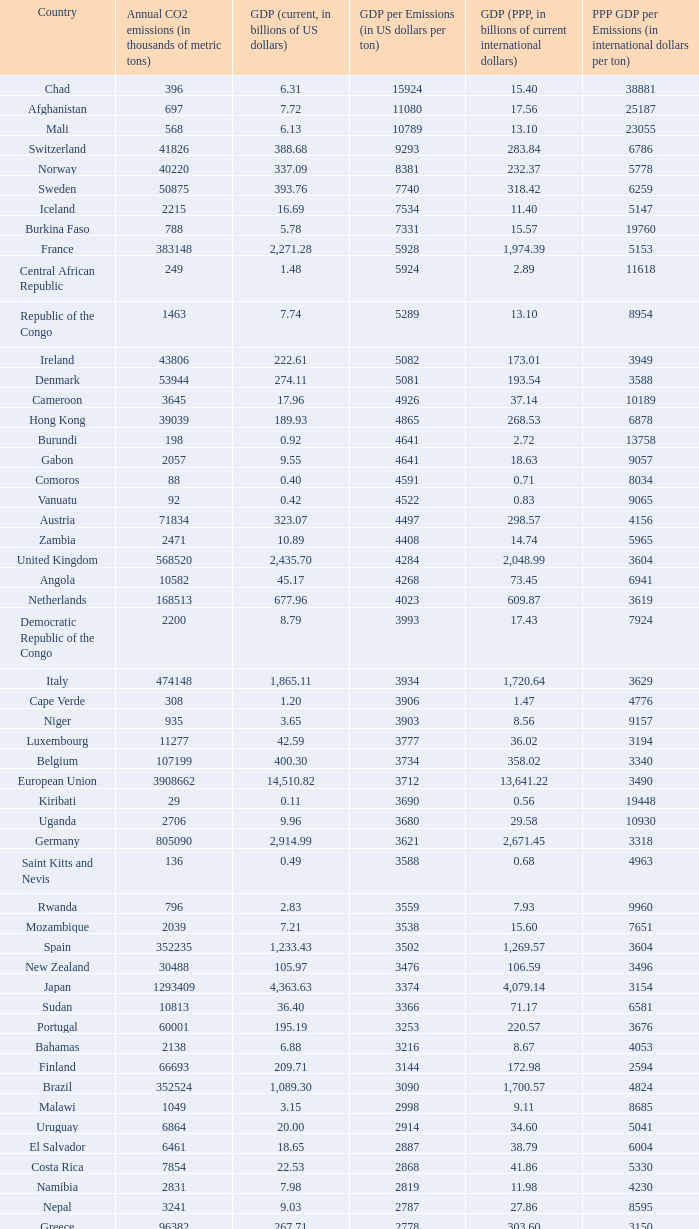What is the highest gdp (ppp, in billions of current international dollars) per emissions (in international dollars per ton) when the gdp (ppp) is 7.93? 9960.0. Parse the full table. {'header': ['Country', 'Annual CO2 emissions (in thousands of metric tons)', 'GDP (current, in billions of US dollars)', 'GDP per Emissions (in US dollars per ton)', 'GDP (PPP, in billions of current international dollars)', 'PPP GDP per Emissions (in international dollars per ton)'], 'rows': [['Chad', '396', '6.31', '15924', '15.40', '38881'], ['Afghanistan', '697', '7.72', '11080', '17.56', '25187'], ['Mali', '568', '6.13', '10789', '13.10', '23055'], ['Switzerland', '41826', '388.68', '9293', '283.84', '6786'], ['Norway', '40220', '337.09', '8381', '232.37', '5778'], ['Sweden', '50875', '393.76', '7740', '318.42', '6259'], ['Iceland', '2215', '16.69', '7534', '11.40', '5147'], ['Burkina Faso', '788', '5.78', '7331', '15.57', '19760'], ['France', '383148', '2,271.28', '5928', '1,974.39', '5153'], ['Central African Republic', '249', '1.48', '5924', '2.89', '11618'], ['Republic of the Congo', '1463', '7.74', '5289', '13.10', '8954'], ['Ireland', '43806', '222.61', '5082', '173.01', '3949'], ['Denmark', '53944', '274.11', '5081', '193.54', '3588'], ['Cameroon', '3645', '17.96', '4926', '37.14', '10189'], ['Hong Kong', '39039', '189.93', '4865', '268.53', '6878'], ['Burundi', '198', '0.92', '4641', '2.72', '13758'], ['Gabon', '2057', '9.55', '4641', '18.63', '9057'], ['Comoros', '88', '0.40', '4591', '0.71', '8034'], ['Vanuatu', '92', '0.42', '4522', '0.83', '9065'], ['Austria', '71834', '323.07', '4497', '298.57', '4156'], ['Zambia', '2471', '10.89', '4408', '14.74', '5965'], ['United Kingdom', '568520', '2,435.70', '4284', '2,048.99', '3604'], ['Angola', '10582', '45.17', '4268', '73.45', '6941'], ['Netherlands', '168513', '677.96', '4023', '609.87', '3619'], ['Democratic Republic of the Congo', '2200', '8.79', '3993', '17.43', '7924'], ['Italy', '474148', '1,865.11', '3934', '1,720.64', '3629'], ['Cape Verde', '308', '1.20', '3906', '1.47', '4776'], ['Niger', '935', '3.65', '3903', '8.56', '9157'], ['Luxembourg', '11277', '42.59', '3777', '36.02', '3194'], ['Belgium', '107199', '400.30', '3734', '358.02', '3340'], ['European Union', '3908662', '14,510.82', '3712', '13,641.22', '3490'], ['Kiribati', '29', '0.11', '3690', '0.56', '19448'], ['Uganda', '2706', '9.96', '3680', '29.58', '10930'], ['Germany', '805090', '2,914.99', '3621', '2,671.45', '3318'], ['Saint Kitts and Nevis', '136', '0.49', '3588', '0.68', '4963'], ['Rwanda', '796', '2.83', '3559', '7.93', '9960'], ['Mozambique', '2039', '7.21', '3538', '15.60', '7651'], ['Spain', '352235', '1,233.43', '3502', '1,269.57', '3604'], ['New Zealand', '30488', '105.97', '3476', '106.59', '3496'], ['Japan', '1293409', '4,363.63', '3374', '4,079.14', '3154'], ['Sudan', '10813', '36.40', '3366', '71.17', '6581'], ['Portugal', '60001', '195.19', '3253', '220.57', '3676'], ['Bahamas', '2138', '6.88', '3216', '8.67', '4053'], ['Finland', '66693', '209.71', '3144', '172.98', '2594'], ['Brazil', '352524', '1,089.30', '3090', '1,700.57', '4824'], ['Malawi', '1049', '3.15', '2998', '9.11', '8685'], ['Uruguay', '6864', '20.00', '2914', '34.60', '5041'], ['El Salvador', '6461', '18.65', '2887', '38.79', '6004'], ['Costa Rica', '7854', '22.53', '2868', '41.86', '5330'], ['Namibia', '2831', '7.98', '2819', '11.98', '4230'], ['Nepal', '3241', '9.03', '2787', '27.86', '8595'], ['Greece', '96382', '267.71', '2778', '303.60', '3150'], ['Samoa', '158', '0.43', '2747', '0.95', '5987'], ['Dominica', '117', '0.32', '2709', '0.66', '5632'], ['Latvia', '7462', '19.94', '2672', '35.22', '4720'], ['Tanzania', '5372', '14.35', '2671', '44.46', '8276'], ['Haiti', '1811', '4.84', '2670', '10.52', '5809'], ['Panama', '6428', '17.13', '2666', '30.21', '4700'], ['Swaziland', '1016', '2.67', '2629', '5.18', '5095'], ['Guatemala', '11766', '30.26', '2572', '57.77', '4910'], ['Slovenia', '15173', '38.94', '2566', '51.14', '3370'], ['Colombia', '63422', '162.50', '2562', '342.77', '5405'], ['Malta', '2548', '6.44', '2528', '8.88', '3485'], ['Ivory Coast', '6882', '17.38', '2526', '31.22', '4536'], ['Ethiopia', '6006', '15.17', '2525', '54.39', '9055'], ['Saint Lucia', '367', '0.93', '2520', '1.69', '4616'], ['Saint Vincent and the Grenadines', '198', '0.50', '2515', '0.96', '4843'], ['Singapore', '56217', '139.18', '2476', '208.75', '3713'], ['Laos', '1426', '3.51', '2459', '11.41', '8000'], ['Bhutan', '381', '0.93', '2444', '2.61', '6850'], ['Chile', '60100', '146.76', '2442', '214.41', '3568'], ['Peru', '38643', '92.31', '2389', '195.99', '5072'], ['Barbados', '1338', '3.19', '2385', '4.80', '3590'], ['Sri Lanka', '11876', '28.28', '2381', '77.51', '6526'], ['Botswana', '4770', '11.30', '2369', '23.51', '4929'], ['Antigua and Barbuda', '425', '1.01', '2367', '1.41', '3315'], ['Cyprus', '7788', '18.43', '2366', '19.99', '2566'], ['Canada', '544680', '1,278.97', '2348', '1,203.74', '2210'], ['Grenada', '242', '0.56', '2331', '1.05', '4331'], ['Paraguay', '3986', '9.28', '2327', '24.81', '6224'], ['United States', '5752289', '13,178.35', '2291', '13,178.35', '2291'], ['Equatorial Guinea', '4356', '9.60', '2205', '15.76', '3618'], ['Senegal', '4261', '9.37', '2198', '19.30', '4529'], ['Eritrea', '554', '1.21', '2186', '3.48', '6283'], ['Mexico', '436150', '952.34', '2184', '1,408.81', '3230'], ['Guinea', '1360', '2.90', '2135', '9.29', '6829'], ['Lithuania', '14190', '30.08', '2120', '54.04', '3808'], ['Albania', '4301', '9.11', '2119', '18.34', '4264'], ['Croatia', '23683', '49.04', '2071', '72.63', '3067'], ['Israel', '70440', '143.98', '2044', '174.61', '2479'], ['Australia', '372013', '755.21', '2030', '713.96', '1919'], ['South Korea', '475248', '952.03', '2003', '1,190.70', '2505'], ['Fiji', '1610', '3.17', '1967', '3.74', '2320'], ['Turkey', '269452', '529.19', '1964', '824.58', '3060'], ['Hungary', '57644', '113.05', '1961', '183.84', '3189'], ['Madagascar', '2834', '5.52', '1947', '16.84', '5943'], ['Brunei', '5911', '11.47', '1940', '18.93', '3203'], ['Timor-Leste', '176', '0.33', '1858', '1.96', '11153'], ['Solomon Islands', '180', '0.33', '1856', '0.86', '4789'], ['Kenya', '12151', '22.52', '1853', '52.74', '4340'], ['Togo', '1221', '2.22', '1818', '4.96', '4066'], ['Tonga', '132', '0.24', '1788', '0.54', '4076'], ['Cambodia', '4074', '7.26', '1783', '23.03', '5653'], ['Dominican Republic', '20357', '35.28', '1733', '63.94', '3141'], ['Philippines', '68328', '117.57', '1721', '272.25', '3984'], ['Bolivia', '6973', '11.53', '1653', '37.37', '5359'], ['Mauritius', '3850', '6.32', '1641', '13.09', '3399'], ['Mauritania', '1665', '2.70', '1621', '5.74', '3448'], ['Djibouti', '488', '0.77', '1576', '1.61', '3297'], ['Bangladesh', '41609', '65.20', '1567', '190.93', '4589'], ['Benin', '3109', '4.74', '1524', '11.29', '3631'], ['Gambia', '334', '0.51', '1521', '1.92', '5743'], ['Nigeria', '97262', '146.89', '1510', '268.21', '2758'], ['Honduras', '7194', '10.84', '1507', '28.20', '3920'], ['Slovakia', '37459', '56.00', '1495', '96.76', '2583'], ['Belize', '818', '1.21', '1483', '2.31', '2823'], ['Lebanon', '15330', '22.44', '1464', '40.46', '2639'], ['Armenia', '4371', '6.38', '1461', '14.68', '3357'], ['Morocco', '45316', '65.64', '1448', '120.32', '2655'], ['Burma', '10025', '14.50', '1447', '55.55', '5541'], ['Sierra Leone', '994', '1.42', '1433', '3.62', '3644'], ['Georgia', '5518', '7.77', '1408', '17.77', '3221'], ['Ghana', '9240', '12.73', '1378', '28.72', '3108'], ['Tunisia', '23126', '31.11', '1345', '70.57', '3052'], ['Ecuador', '31328', '41.40', '1322', '94.48', '3016'], ['Seychelles', '744', '0.97', '1301', '1.61', '2157'], ['Romania', '98490', '122.70', '1246', '226.51', '2300'], ['Qatar', '46193', '56.92', '1232', '66.90', '1448'], ['Argentina', '173536', '212.71', '1226', '469.75', '2707'], ['Czech Republic', '116991', '142.31', '1216', '228.48', '1953'], ['Nicaragua', '4334', '5.26', '1215', '14.93', '3444'], ['São Tomé and Príncipe', '103', '0.13', '1214', '0.24', '2311'], ['Papua New Guinea', '4620', '5.61', '1213', '10.91', '2361'], ['United Arab Emirates', '139553', '164.17', '1176', '154.35', '1106'], ['Kuwait', '86599', '101.56', '1173', '119.96', '1385'], ['Guinea-Bissau', '279', '0.32', '1136', '0.76', '2724'], ['Indonesia', '333483', '364.35', '1093', '767.92', '2303'], ['Venezuela', '171593', '184.25', '1074', '300.80', '1753'], ['Poland', '318219', '341.67', '1074', '567.94', '1785'], ['Maldives', '869', '0.92', '1053', '1.44', '1654'], ['Libya', '55495', '55.08', '992', '75.47', '1360'], ['Jamaica', '12151', '11.45', '942', '19.93', '1640'], ['Estonia', '17523', '16.45', '939', '25.31', '1444'], ['Saudi Arabia', '381564', '356.63', '935', '522.12', '1368'], ['Yemen', '21201', '19.06', '899', '49.21', '2321'], ['Pakistan', '142659', '127.49', '894', '372.96', '2614'], ['Algeria', '132715', '116.83', '880', '209.40', '1578'], ['Suriname', '2438', '2.14', '878', '3.76', '1543'], ['Oman', '41378', '35.73', '863', '56.44', '1364'], ['Malaysia', '187865', '156.86', '835', '328.97', '1751'], ['Liberia', '785', '0.61', '780', '1.19', '1520'], ['Thailand', '272521', '206.99', '760', '483.56', '1774'], ['Bahrain', '21292', '15.85', '744', '22.41', '1053'], ['Jordan', '20724', '14.84', '716', '26.25', '1266'], ['Bulgaria', '48085', '31.69', '659', '79.24', '1648'], ['Egypt', '166800', '107.38', '644', '367.64', '2204'], ['Russia', '1564669', '989.43', '632', '1,887.61', '1206'], ['South Africa', '414649', '257.89', '622', '433.51', '1045'], ['Serbia and Montenegro', '53266', '32.30', '606', '72.93', '1369'], ['Guyana', '1507', '0.91', '606', '2.70', '1792'], ['Azerbaijan', '35050', '21.03', '600', '51.71', '1475'], ['Macedonia', '10875', '6.38', '587', '16.14', '1484'], ['India', '1510351', '874.77', '579', '2,672.66', '1770'], ['Trinidad and Tobago', '33601', '19.38', '577', '23.62', '703'], ['Vietnam', '106132', '60.93', '574', '198.94', '1874'], ['Belarus', '68849', '36.96', '537', '94.80', '1377'], ['Iraq', '92572', '49.27', '532', '90.51', '978'], ['Kyrgyzstan', '5566', '2.84', '510', '9.45', '1698'], ['Zimbabwe', '11081', '5.60', '505', '2.29', '207'], ['Syria', '68460', '33.51', '489', '82.09', '1199'], ['Turkmenistan', '44103', '21.40', '485', '23.40', '531'], ['Iran', '466976', '222.13', '476', '693.32', '1485'], ['Bosnia and Herzegovina', '27438', '12.28', '447', '25.70', '937'], ['Tajikistan', '6391', '2.81', '440', '10.69', '1672'], ['Moldova', '7821', '3.41', '436', '9.19', '1175'], ['China', '6103493', '2,657.84', '435', '6,122.24', '1003'], ['Kazakhstan', '193508', '81.00', '419', '150.56', '778'], ['Ukraine', '319158', '108.00', '338', '291.30', '913'], ['Mongolia', '9442', '3.16', '334', '7.47', '791']]} 